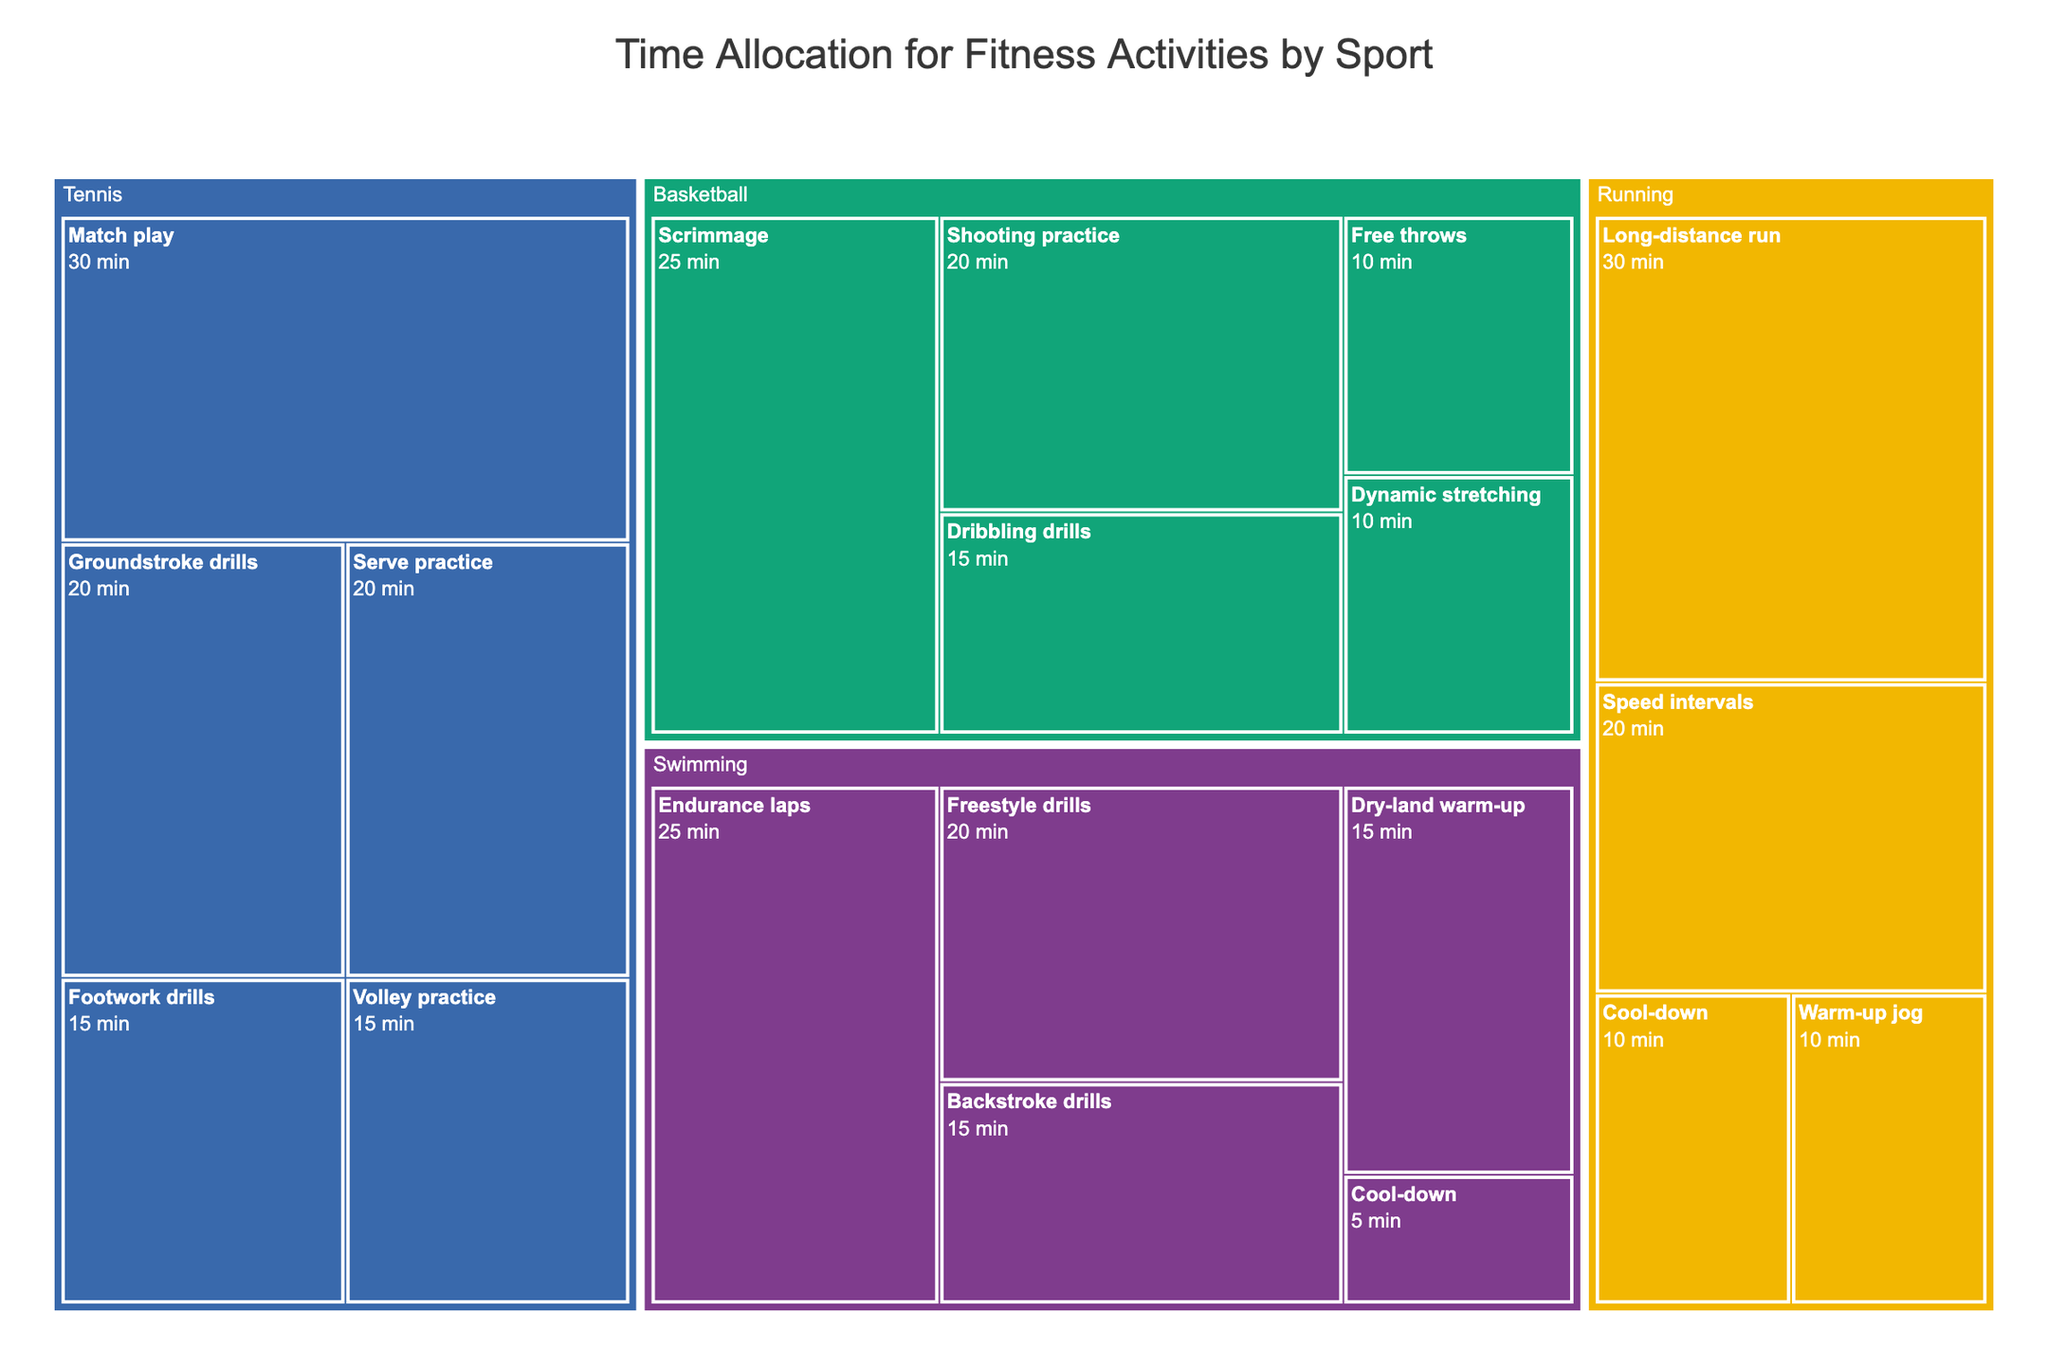what is the total time allocated for Running activities? To find the total time for Running activities, sum the time for all running activities: 10 (Warm-up jog) + 20 (Speed intervals) + 30 (Long-distance run) + 10 (Cool-down) = 70 minutes
Answer: 70 minutes Which activity in Swimming takes the most time? In the Swimming section, identify the activity with the highest time allocation: Endurance laps with 25 minutes has the highest time
Answer: Endurance laps How many fitness activities are there in total across all sports? Count all the individual activities listed for Running, Swimming, Basketball, and Tennis: 4 (Running) + 5 (Swimming) + 5 (Basketball) + 5 (Tennis) = 19 activities
Answer: 19 activities Which sport has the largest single activity time and what is it? Look for the single largest time allocation in each sport and compare: Running's Long-distance run (30 min), Swimming's Endurance laps (25 min), Basketball's Scrimmage (25 min), Tennis' Match play (30 min). The largest time is Running's Long-distance run or Tennis' Match play, both 30 minutes
Answer: Long-distance run or Match play What is the average time allocated to each activity in Basketball? Calculate the average by summing up all the time for Basketball activities and dividing by the number of activities: (10 + 20 + 15 + 25 + 10) / 5 = 80 / 5 = 16 minutes
Answer: 16 minutes Which sport has the least total time allocated? Calculate the total time for each sport and compare: Running (70 min), Swimming (80 min), Basketball (80 min), Tennis (100 min). The least total time is Running with 70 minutes
Answer: Running Is there an activity in any sport that takes exactly 20 minutes? If so, name it. Scan through each activity time to see if there is one with exactly 20 minutes: Running (Speed intervals), Swimming (Freestyle drills), Basketball (Shooting practice), Tennis (Serve practice and Groundstroke drills) all have activities of exactly 20 minutes.
Answer: Speed intervals, Freestyle drills, Shooting practice, Serve practice, Groundstroke drills What is the combined time for all warm-up activities across all sports? Sum the times for all activities related to warm-up: 10 (Running's Warm-up jog) + 15 (Swimming's Dry-land warm-up) + 10 (Basketball's Dynamic stretching) + 15 (Tennis' Footwork drills) = 50 minutes
Answer: 50 minutes Which sport has the highest variety of activities? Compare the number of activities listed for each sport: Running (4 activities), Swimming (5 activities), Basketball (5 activities), Tennis (5 activities). The highest variety (most activities) is in Swimming, Basketball, and Tennis, all having 5 activities
Answer: Swimming, Basketball, Tennis 